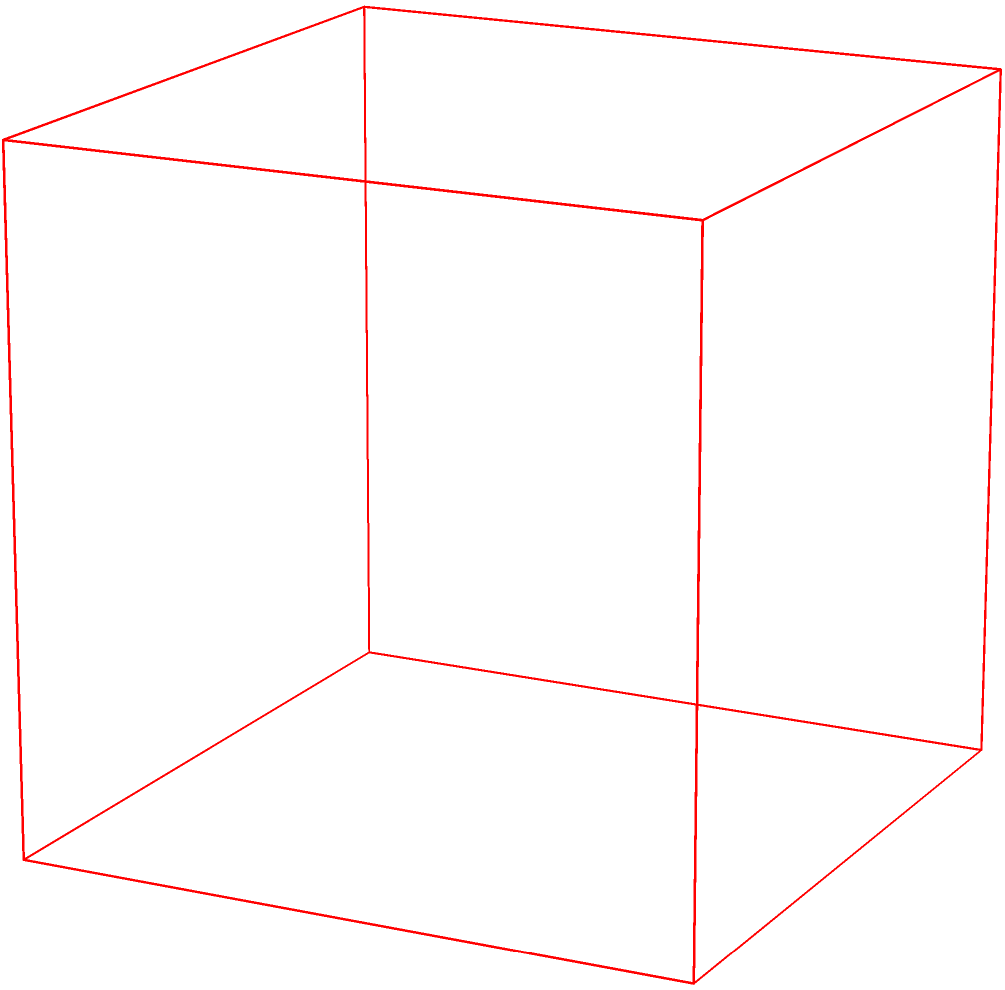The image shows two manufacturing machines, A and B, from a perspective view. Based on their configurations, which machine is likely to be more energy-efficient in a sustainable manufacturing setting? To determine which machine is more energy-efficient, we need to analyze their configurations:

1. Size: Machine B appears smaller overall compared to Machine A. Smaller machines generally require less energy to operate.

2. Compactness: Machine B has a more compact design, with its upper cylindrical component being shorter and narrower. This suggests less material usage and potentially lower energy requirements.

3. Color coding: In industrial settings, green often symbolizes efficiency or eco-friendliness, while red may indicate less efficient or more energy-intensive equipment.

4. Proportions: The cylindrical component of Machine B is proportionally smaller compared to its base, suggesting a more optimized design that could lead to better energy efficiency.

5. Sustainable manufacturing principles: In sustainability studies, we learn that reducing size, optimizing design, and improving efficiency are key strategies for creating more sustainable manufacturing processes.

Given these observations and applying sustainability principles, Machine B is more likely to be the energy-efficient option in a sustainable manufacturing setting.
Answer: Machine B 